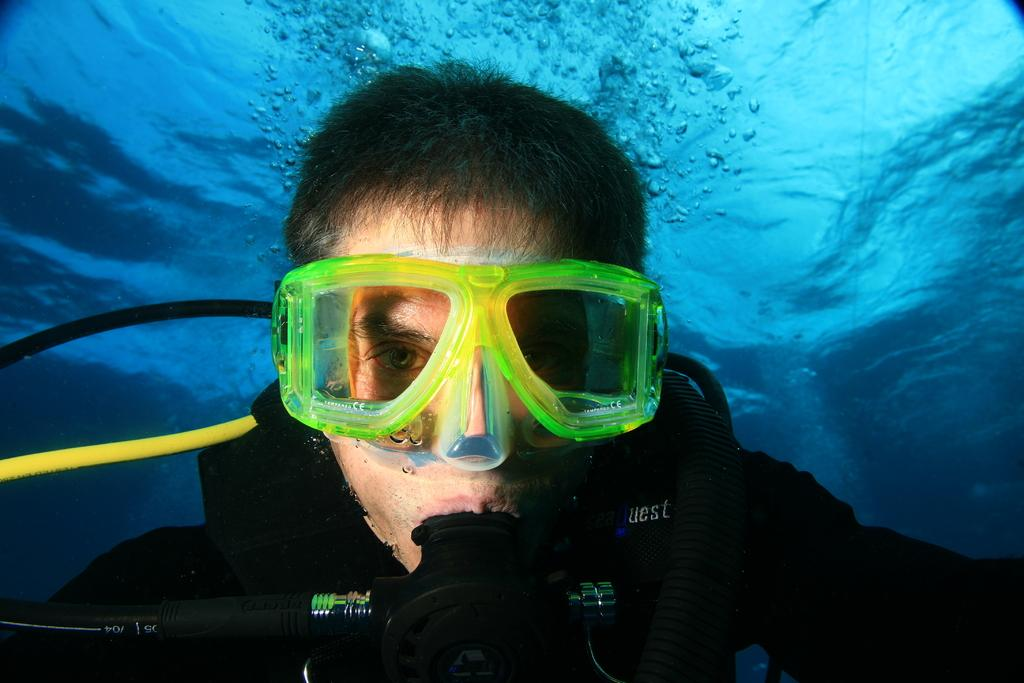What is the man in the image doing? The man is in the water. Can you describe the man's appearance in the image? The man is wearing spectacles. What type of house is visible in the image? There is no house present in the image; it features a man in the water wearing spectacles. What rhythm is the man following while in the water? There is no indication of a rhythm in the image; the man is simply in the water. 